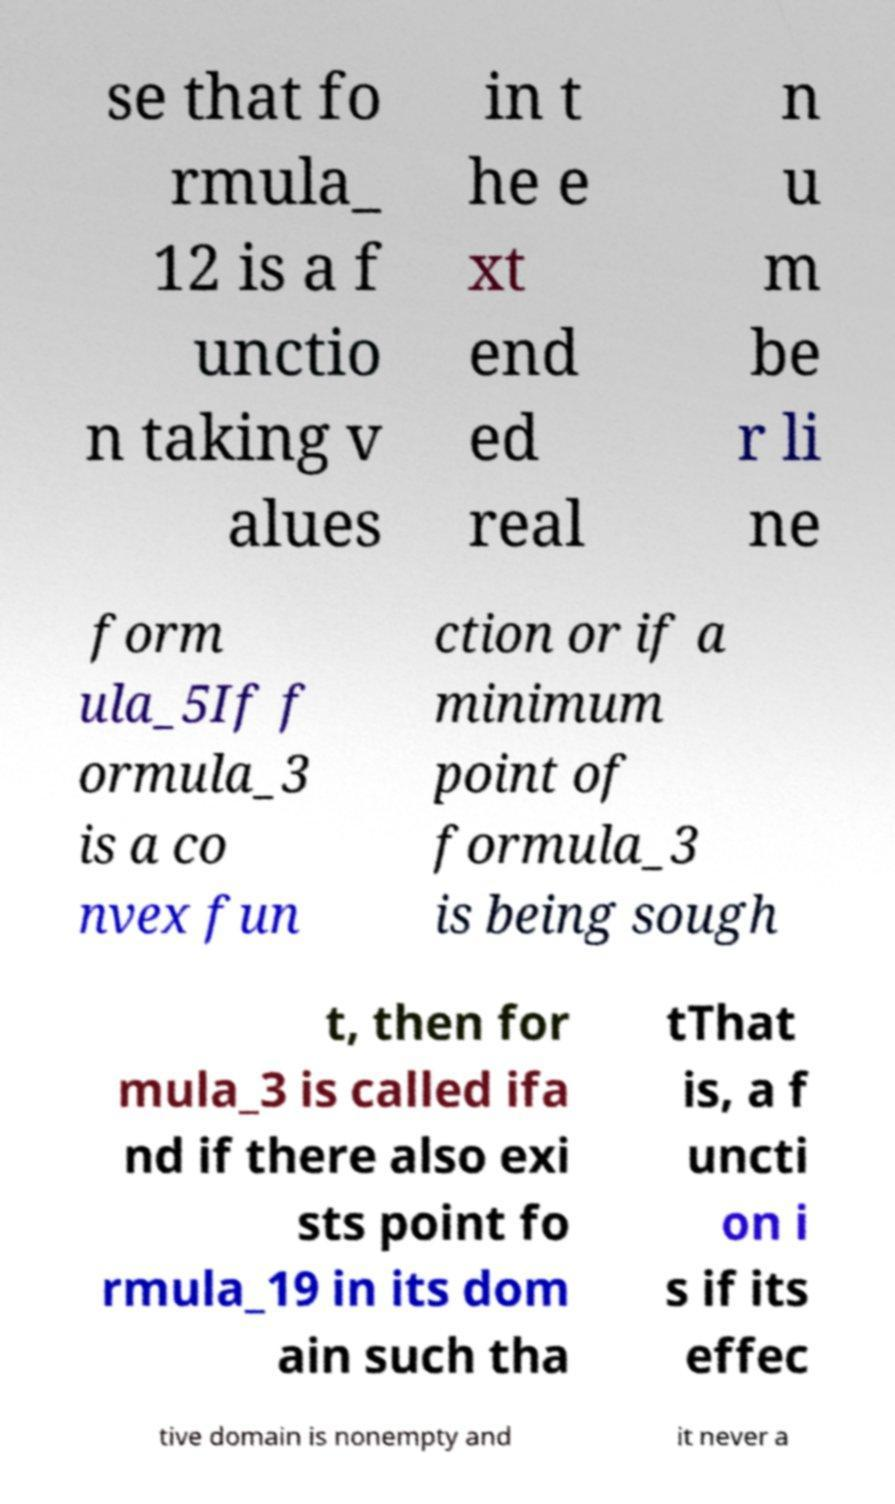Can you read and provide the text displayed in the image?This photo seems to have some interesting text. Can you extract and type it out for me? se that fo rmula_ 12 is a f unctio n taking v alues in t he e xt end ed real n u m be r li ne form ula_5If f ormula_3 is a co nvex fun ction or if a minimum point of formula_3 is being sough t, then for mula_3 is called ifa nd if there also exi sts point fo rmula_19 in its dom ain such tha tThat is, a f uncti on i s if its effec tive domain is nonempty and it never a 